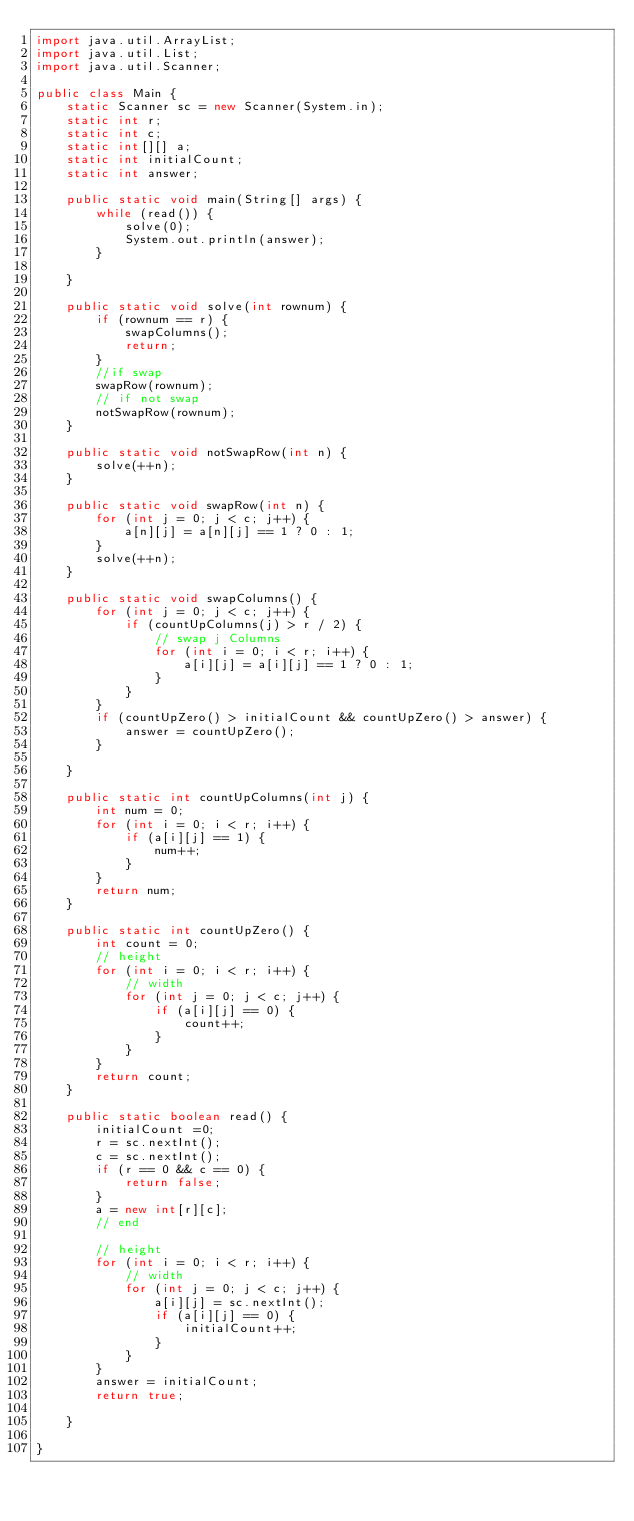<code> <loc_0><loc_0><loc_500><loc_500><_Java_>import java.util.ArrayList;
import java.util.List;
import java.util.Scanner;

public class Main {
	static Scanner sc = new Scanner(System.in);
	static int r;
	static int c;
	static int[][] a;
	static int initialCount;
	static int answer;

	public static void main(String[] args) {
		while (read()) {
			solve(0);
			System.out.println(answer);
		}
		
	}

	public static void solve(int rownum) {
		if (rownum == r) {
			swapColumns();
			return;
		}
		//if swap
		swapRow(rownum);
		// if not swap
		notSwapRow(rownum);
	}

	public static void notSwapRow(int n) {
		solve(++n);
	}

	public static void swapRow(int n) {
		for (int j = 0; j < c; j++) {
			a[n][j] = a[n][j] == 1 ? 0 : 1;
		}
		solve(++n);
	}

	public static void swapColumns() {
		for (int j = 0; j < c; j++) {
			if (countUpColumns(j) > r / 2) {
				// swap j Columns
				for (int i = 0; i < r; i++) {
					a[i][j] = a[i][j] == 1 ? 0 : 1;
				}
			}
		}
		if (countUpZero() > initialCount && countUpZero() > answer) {
			answer = countUpZero();
		}

	}

	public static int countUpColumns(int j) {
		int num = 0;
		for (int i = 0; i < r; i++) {
			if (a[i][j] == 1) {
				num++;
			}
		}
		return num;
	}

	public static int countUpZero() {
		int count = 0;
		// height
		for (int i = 0; i < r; i++) {
			// width
			for (int j = 0; j < c; j++) {
				if (a[i][j] == 0) {
					count++;
				}
			}
		}
		return count;
	}

	public static boolean read() {
		initialCount =0;
		r = sc.nextInt();
		c = sc.nextInt();
		if (r == 0 && c == 0) {
			return false;
		}
		a = new int[r][c];
		// end

		// height
		for (int i = 0; i < r; i++) {
			// width
			for (int j = 0; j < c; j++) {
				a[i][j] = sc.nextInt();
				if (a[i][j] == 0) {
					initialCount++;
				}
			}
		}
		answer = initialCount;
		return true;

	}

}</code> 